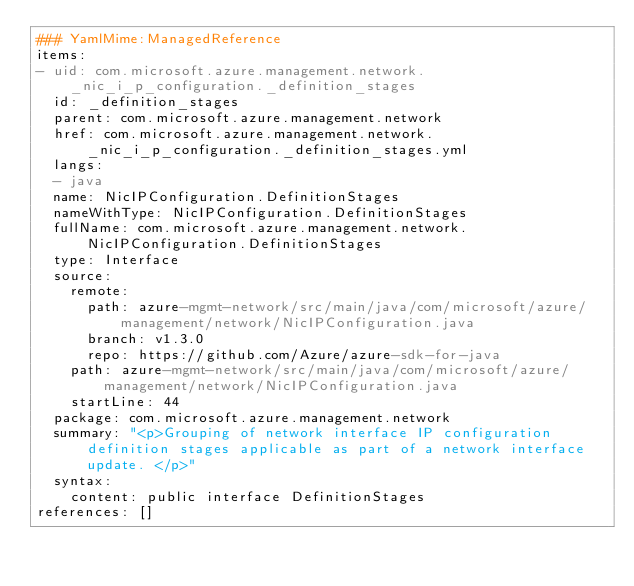<code> <loc_0><loc_0><loc_500><loc_500><_YAML_>### YamlMime:ManagedReference
items:
- uid: com.microsoft.azure.management.network._nic_i_p_configuration._definition_stages
  id: _definition_stages
  parent: com.microsoft.azure.management.network
  href: com.microsoft.azure.management.network._nic_i_p_configuration._definition_stages.yml
  langs:
  - java
  name: NicIPConfiguration.DefinitionStages
  nameWithType: NicIPConfiguration.DefinitionStages
  fullName: com.microsoft.azure.management.network.NicIPConfiguration.DefinitionStages
  type: Interface
  source:
    remote:
      path: azure-mgmt-network/src/main/java/com/microsoft/azure/management/network/NicIPConfiguration.java
      branch: v1.3.0
      repo: https://github.com/Azure/azure-sdk-for-java
    path: azure-mgmt-network/src/main/java/com/microsoft/azure/management/network/NicIPConfiguration.java
    startLine: 44
  package: com.microsoft.azure.management.network
  summary: "<p>Grouping of network interface IP configuration definition stages applicable as part of a network interface update. </p>"
  syntax:
    content: public interface DefinitionStages
references: []
</code> 